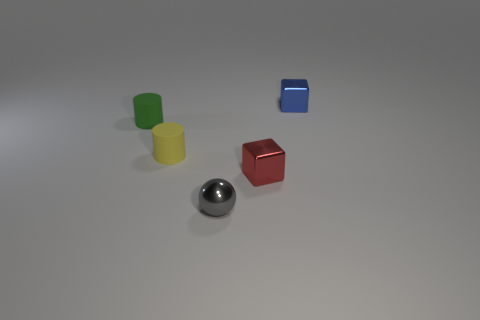Add 1 cyan rubber things. How many objects exist? 6 Subtract all spheres. How many objects are left? 4 Add 3 big blue metal things. How many big blue metal things exist? 3 Subtract 1 red cubes. How many objects are left? 4 Subtract all big red rubber spheres. Subtract all green rubber cylinders. How many objects are left? 4 Add 5 tiny metal objects. How many tiny metal objects are left? 8 